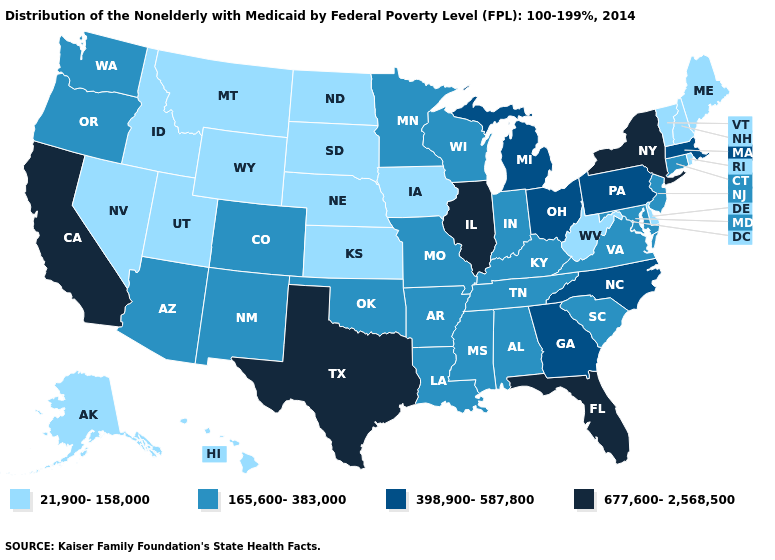What is the value of Alaska?
Give a very brief answer. 21,900-158,000. What is the highest value in states that border New York?
Write a very short answer. 398,900-587,800. Name the states that have a value in the range 165,600-383,000?
Short answer required. Alabama, Arizona, Arkansas, Colorado, Connecticut, Indiana, Kentucky, Louisiana, Maryland, Minnesota, Mississippi, Missouri, New Jersey, New Mexico, Oklahoma, Oregon, South Carolina, Tennessee, Virginia, Washington, Wisconsin. Which states have the highest value in the USA?
Answer briefly. California, Florida, Illinois, New York, Texas. What is the value of Tennessee?
Write a very short answer. 165,600-383,000. What is the value of Kansas?
Quick response, please. 21,900-158,000. Name the states that have a value in the range 677,600-2,568,500?
Quick response, please. California, Florida, Illinois, New York, Texas. Does Montana have the same value as Maine?
Give a very brief answer. Yes. What is the value of Idaho?
Concise answer only. 21,900-158,000. Does Wisconsin have the lowest value in the MidWest?
Give a very brief answer. No. Which states hav the highest value in the Northeast?
Write a very short answer. New York. Name the states that have a value in the range 165,600-383,000?
Keep it brief. Alabama, Arizona, Arkansas, Colorado, Connecticut, Indiana, Kentucky, Louisiana, Maryland, Minnesota, Mississippi, Missouri, New Jersey, New Mexico, Oklahoma, Oregon, South Carolina, Tennessee, Virginia, Washington, Wisconsin. Among the states that border Georgia , does North Carolina have the highest value?
Answer briefly. No. Name the states that have a value in the range 165,600-383,000?
Give a very brief answer. Alabama, Arizona, Arkansas, Colorado, Connecticut, Indiana, Kentucky, Louisiana, Maryland, Minnesota, Mississippi, Missouri, New Jersey, New Mexico, Oklahoma, Oregon, South Carolina, Tennessee, Virginia, Washington, Wisconsin. Name the states that have a value in the range 398,900-587,800?
Concise answer only. Georgia, Massachusetts, Michigan, North Carolina, Ohio, Pennsylvania. 